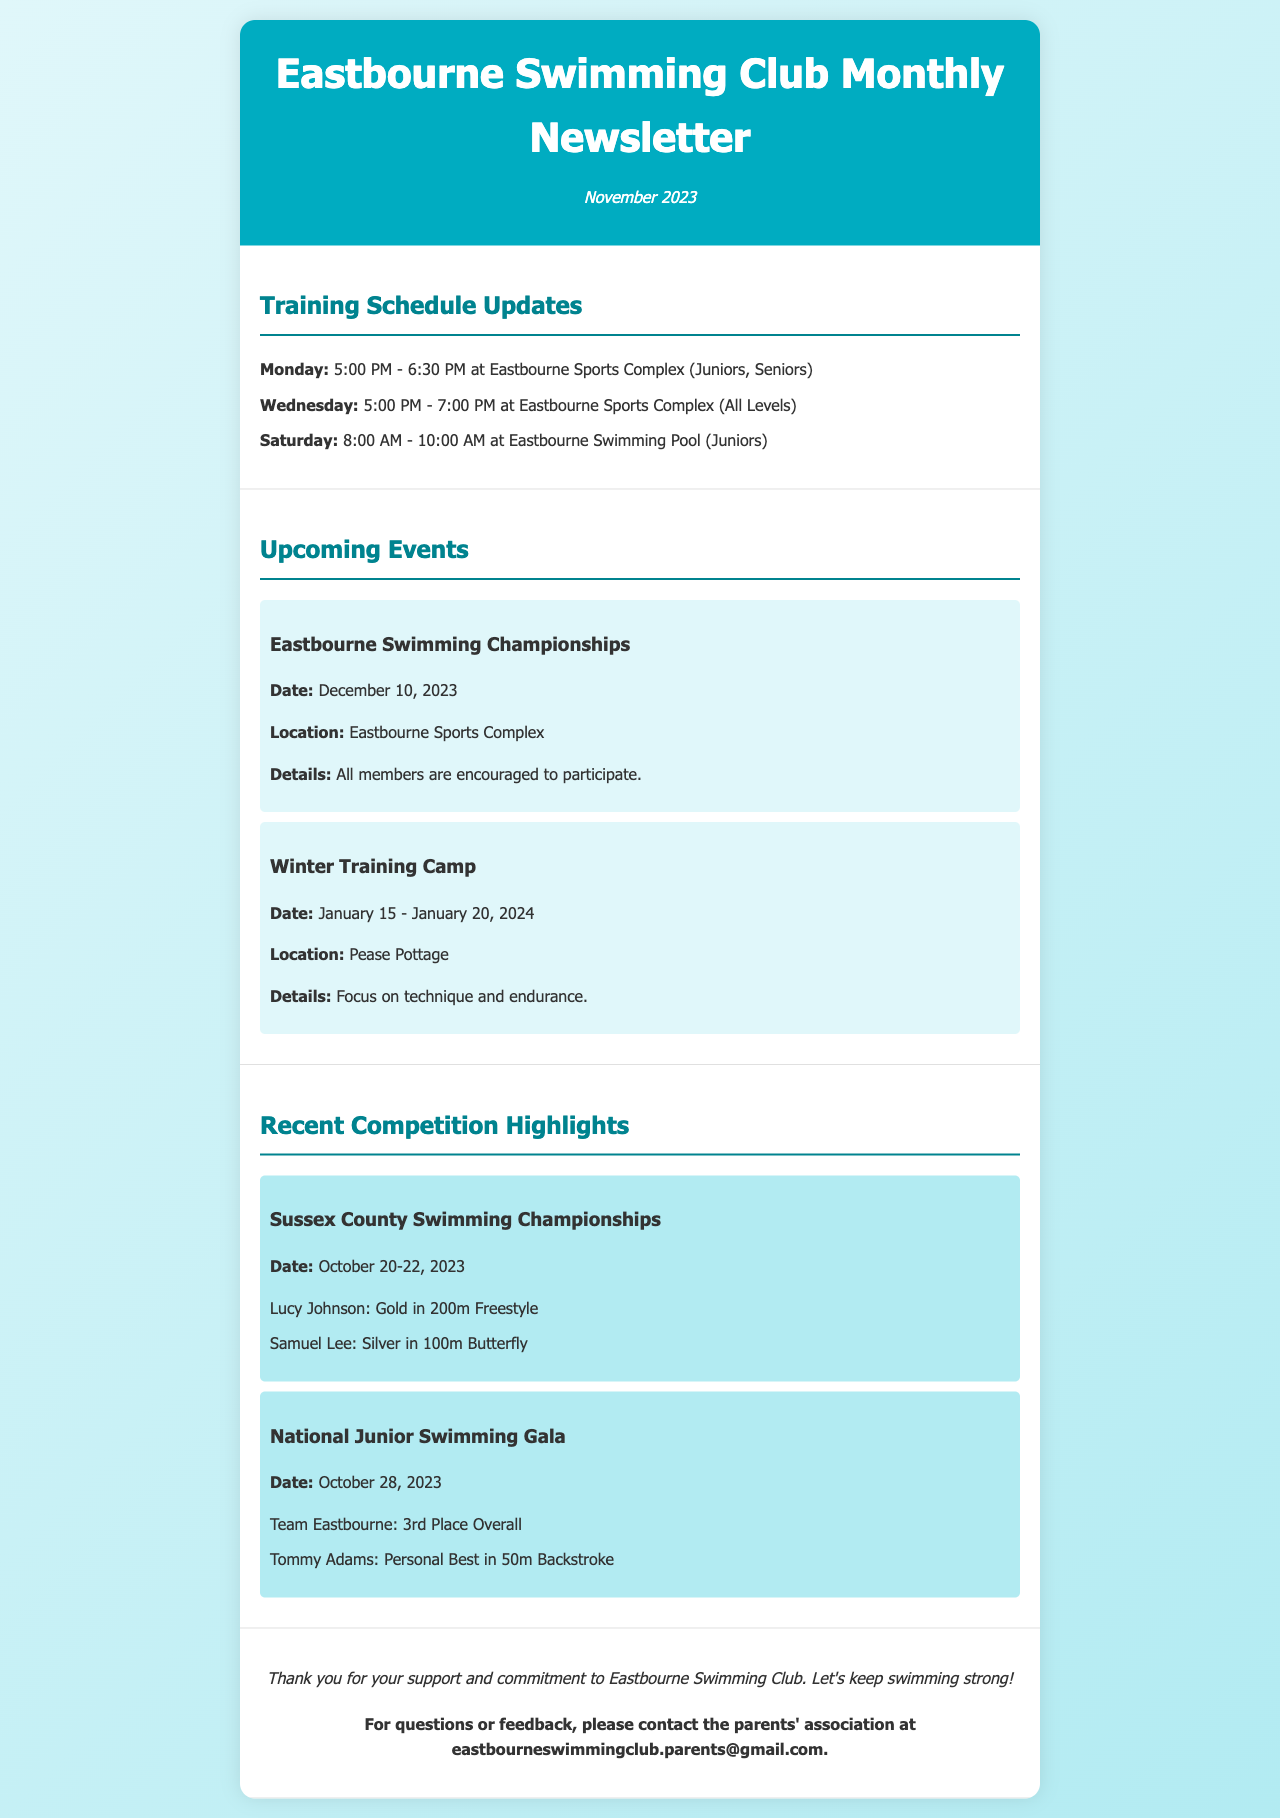what is the date of the Eastbourne Swimming Championships? The document specifies the date for the Eastbourne Swimming Championships as December 10, 2023.
Answer: December 10, 2023 what are the training times on Monday? According to the training schedule, the training on Monday is from 5:00 PM to 6:30 PM.
Answer: 5:00 PM - 6:30 PM who achieved gold in the 200m Freestyle at the Sussex County Swimming Championships? The document lists Lucy Johnson as the gold medalist in the 200m Freestyle at the Sussex County Swimming Championships.
Answer: Lucy Johnson how long is the Winter Training Camp scheduled for? The Winter Training Camp is scheduled to run from January 15 to January 20, 2024, totaling six days.
Answer: January 15 - January 20, 2024 how did Team Eastbourne perform at the National Junior Swimming Gala? The document states that Team Eastbourne secured 3rd place overall at the National Junior Swimming Gala.
Answer: 3rd Place Overall what location is specified for the upcoming Winter Training Camp? The document details that the Winter Training Camp will take place at Pease Pottage.
Answer: Pease Pottage what is the contact email for the parents' association? The email provided for the parents' association in the document is eastbourneswimmingclub.parents@gmail.com.
Answer: eastbourneswimmingclub.parents@gmail.com which swimmer achieved a personal best in the 50m Backstroke? Tommy Adams is mentioned in the document as having achieved a personal best in the 50m Backstroke at the National Junior Swimming Gala.
Answer: Tommy Adams 